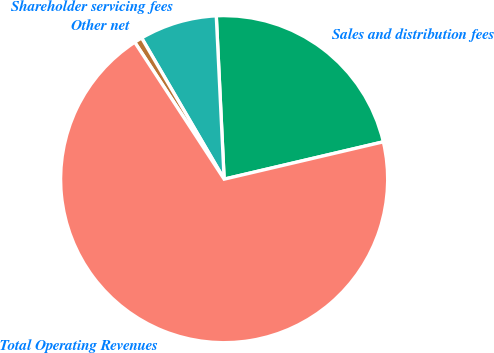<chart> <loc_0><loc_0><loc_500><loc_500><pie_chart><fcel>Sales and distribution fees<fcel>Shareholder servicing fees<fcel>Other net<fcel>Total Operating Revenues<nl><fcel>22.1%<fcel>7.65%<fcel>0.79%<fcel>69.46%<nl></chart> 